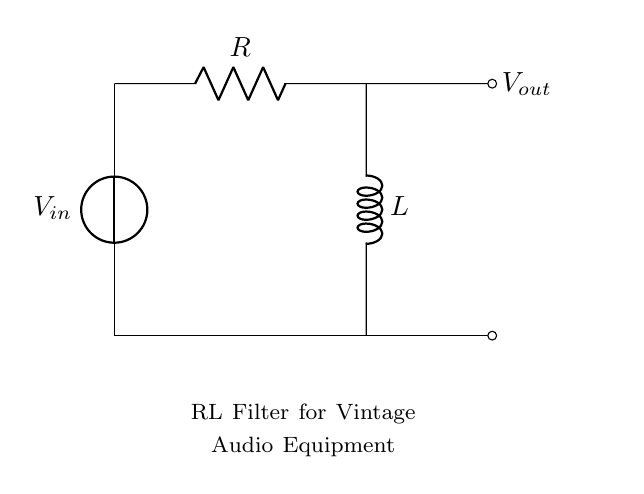What type of filter is represented in the circuit? The circuit depicts an RL filter, which comes from its configuration of a resistor and an inductor in series. Filters are designed to allow certain frequencies to pass while attenuating others, and the presence of the resistor and inductor identifies it as an RL filter.
Answer: RL filter What are the components used in this circuit? The components in the circuit are a resistor and an inductor, which are essential parts of the RL filter. The circuit diagram clearly labels these elements.
Answer: Resistor and Inductor What is the purpose of this RL filter circuit? The purpose of the circuit is to reduce noise in vintage audio equipment used for voice training, as indicated by the text labeling in the diagram. This functionality helps to clean up the audio signal by filtering out unwanted frequencies.
Answer: Noise reduction Where is the output voltage taken from in the circuit? The output voltage, labeled as Vout, is taken from the connection point following the inductor, which signifies the point where filtered audio is available. The output is marked specifically in the diagram.
Answer: After the inductor What is the effect of the inductor in this circuit? The inductor in this RL filter provides inductive reactance, which helps to limit high-frequency noise by storing energy in a magnetic field and releasing it at a later time, effectively filtering the signal. This is particularly important for maintaining signal integrity in audio applications.
Answer: Provides inductive reactance How does the resistor affect the filter's performance? The resistor in the circuit introduces resistance that helps to dampen the circuit's response, controlling the time constant and affecting the cutoff frequency of the filter. Thus, it plays a critical role in balancing the trade-off between desired signal amplitude and noise reduction.
Answer: Damps the response 